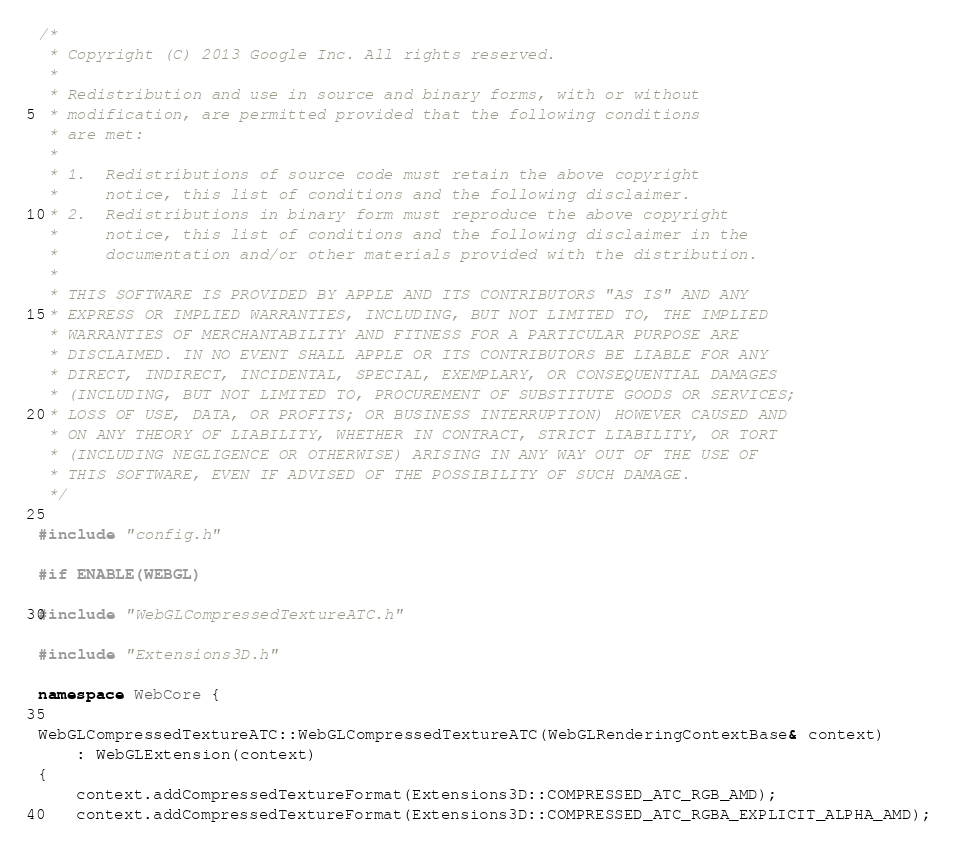<code> <loc_0><loc_0><loc_500><loc_500><_C++_>/*
 * Copyright (C) 2013 Google Inc. All rights reserved.
 *
 * Redistribution and use in source and binary forms, with or without
 * modification, are permitted provided that the following conditions
 * are met:
 *
 * 1.  Redistributions of source code must retain the above copyright
 *     notice, this list of conditions and the following disclaimer.
 * 2.  Redistributions in binary form must reproduce the above copyright
 *     notice, this list of conditions and the following disclaimer in the
 *     documentation and/or other materials provided with the distribution.
 *
 * THIS SOFTWARE IS PROVIDED BY APPLE AND ITS CONTRIBUTORS "AS IS" AND ANY
 * EXPRESS OR IMPLIED WARRANTIES, INCLUDING, BUT NOT LIMITED TO, THE IMPLIED
 * WARRANTIES OF MERCHANTABILITY AND FITNESS FOR A PARTICULAR PURPOSE ARE
 * DISCLAIMED. IN NO EVENT SHALL APPLE OR ITS CONTRIBUTORS BE LIABLE FOR ANY
 * DIRECT, INDIRECT, INCIDENTAL, SPECIAL, EXEMPLARY, OR CONSEQUENTIAL DAMAGES
 * (INCLUDING, BUT NOT LIMITED TO, PROCUREMENT OF SUBSTITUTE GOODS OR SERVICES;
 * LOSS OF USE, DATA, OR PROFITS; OR BUSINESS INTERRUPTION) HOWEVER CAUSED AND
 * ON ANY THEORY OF LIABILITY, WHETHER IN CONTRACT, STRICT LIABILITY, OR TORT
 * (INCLUDING NEGLIGENCE OR OTHERWISE) ARISING IN ANY WAY OUT OF THE USE OF
 * THIS SOFTWARE, EVEN IF ADVISED OF THE POSSIBILITY OF SUCH DAMAGE.
 */

#include "config.h"

#if ENABLE(WEBGL)

#include "WebGLCompressedTextureATC.h"

#include "Extensions3D.h"

namespace WebCore {

WebGLCompressedTextureATC::WebGLCompressedTextureATC(WebGLRenderingContextBase& context)
    : WebGLExtension(context)
{
    context.addCompressedTextureFormat(Extensions3D::COMPRESSED_ATC_RGB_AMD);
    context.addCompressedTextureFormat(Extensions3D::COMPRESSED_ATC_RGBA_EXPLICIT_ALPHA_AMD);</code> 